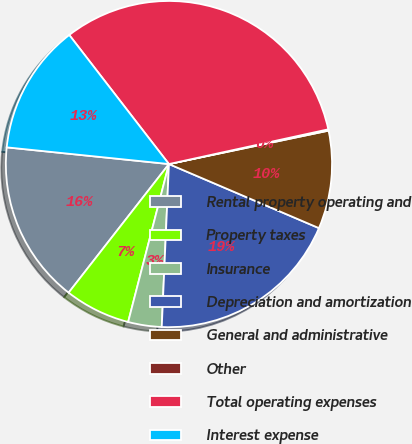Convert chart. <chart><loc_0><loc_0><loc_500><loc_500><pie_chart><fcel>Rental property operating and<fcel>Property taxes<fcel>Insurance<fcel>Depreciation and amortization<fcel>General and administrative<fcel>Other<fcel>Total operating expenses<fcel>Interest expense<nl><fcel>16.09%<fcel>6.52%<fcel>3.32%<fcel>19.28%<fcel>9.71%<fcel>0.13%<fcel>32.05%<fcel>12.9%<nl></chart> 